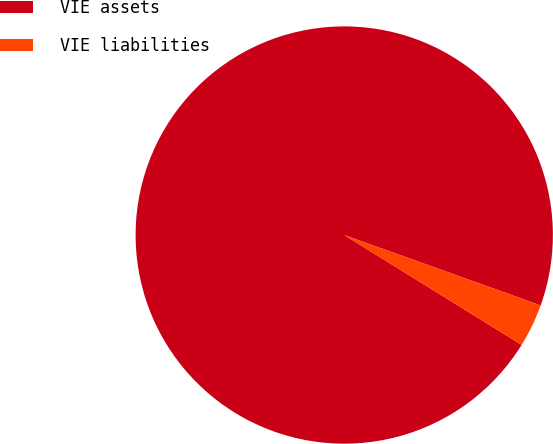<chart> <loc_0><loc_0><loc_500><loc_500><pie_chart><fcel>VIE assets<fcel>VIE liabilities<nl><fcel>96.65%<fcel>3.35%<nl></chart> 